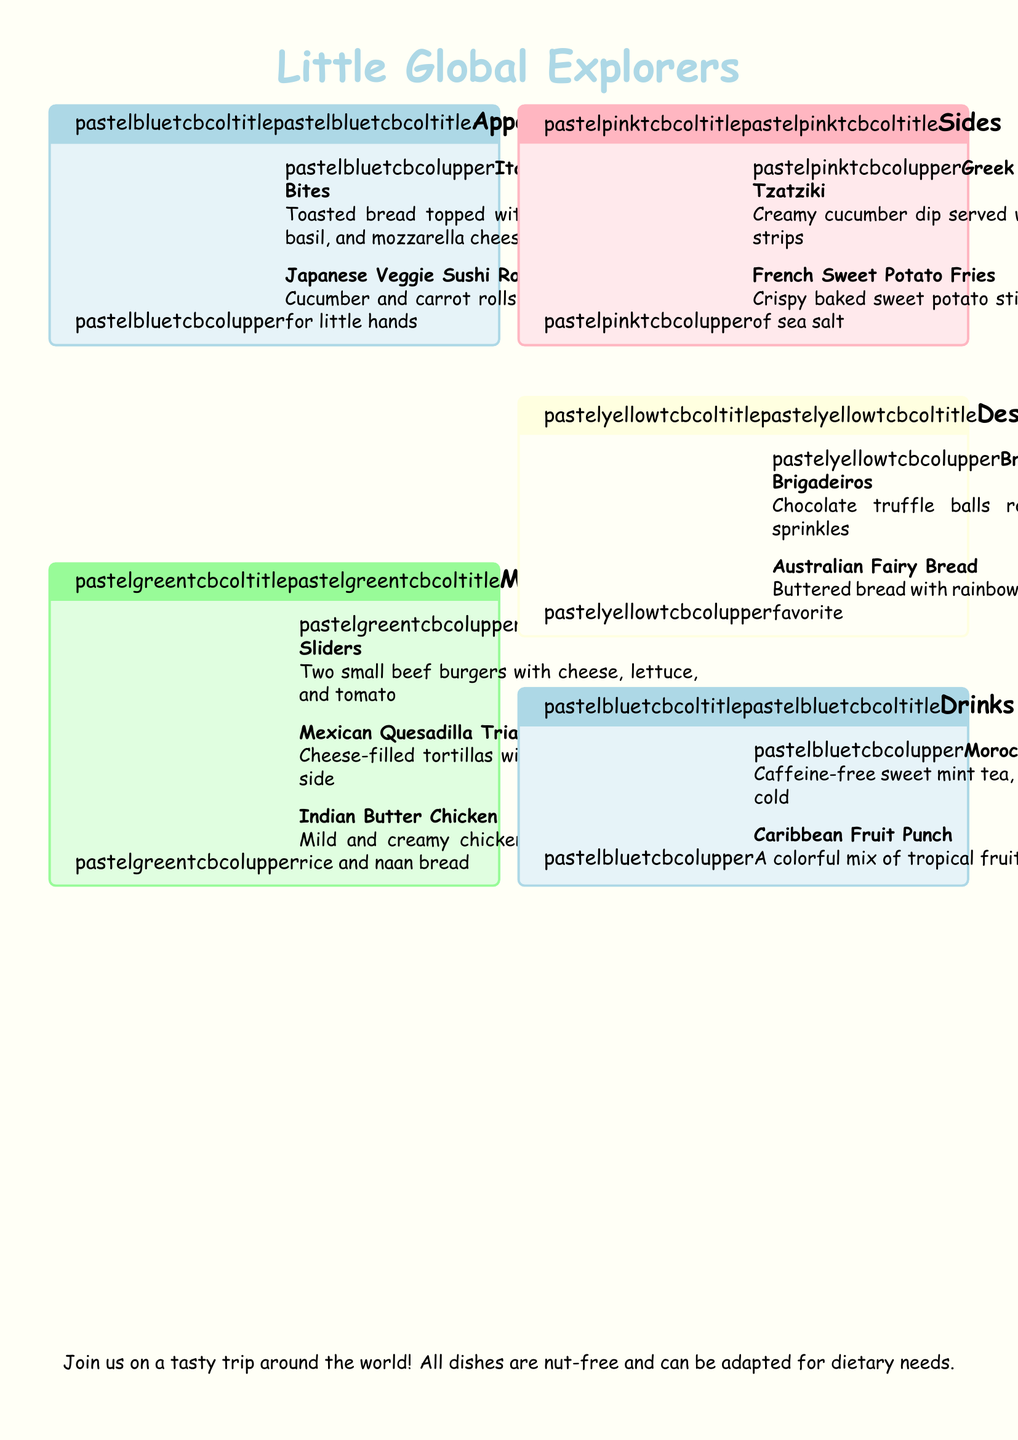What is the title of the menu? The title, prominently displayed at the top of the menu, is the name of the restaurant's theme.
Answer: Little Global Explorers How many main courses are listed? The main courses section contains the names of various dishes, which can be counted.
Answer: 3 Which country is the dish "Butter Chicken" from? The menu specifies the origin of each dish, and "Butter Chicken" is identified with its respective country.
Answer: India What type of drink is offered that is caffeine-free? The drinks section provides details about the beverages, including their caffeine content.
Answer: Moroccan Mint Tea What is the main ingredient in the "Quesadilla Triangles"? The description of this dish focuses on its primary filling as mentioned in the menu.
Answer: Cheese Which dessert is a party favorite? The menu highlights certain desserts by describing their popularity in a celebratory context.
Answer: Australian Fairy Bread What color are the Brigadeiros rolled in? The dessert's description includes details about its appearance, specifically its coating.
Answer: Colorful sprinkles How many appetizers are there on the menu? The appetizers section lists the number of available dishes, which can be tallied.
Answer: 2 What is served with the "Greek Yogurt Tzatziki"? The sides section provides additional information about what accompaniment comes with this dip.
Answer: Pita bread strips 